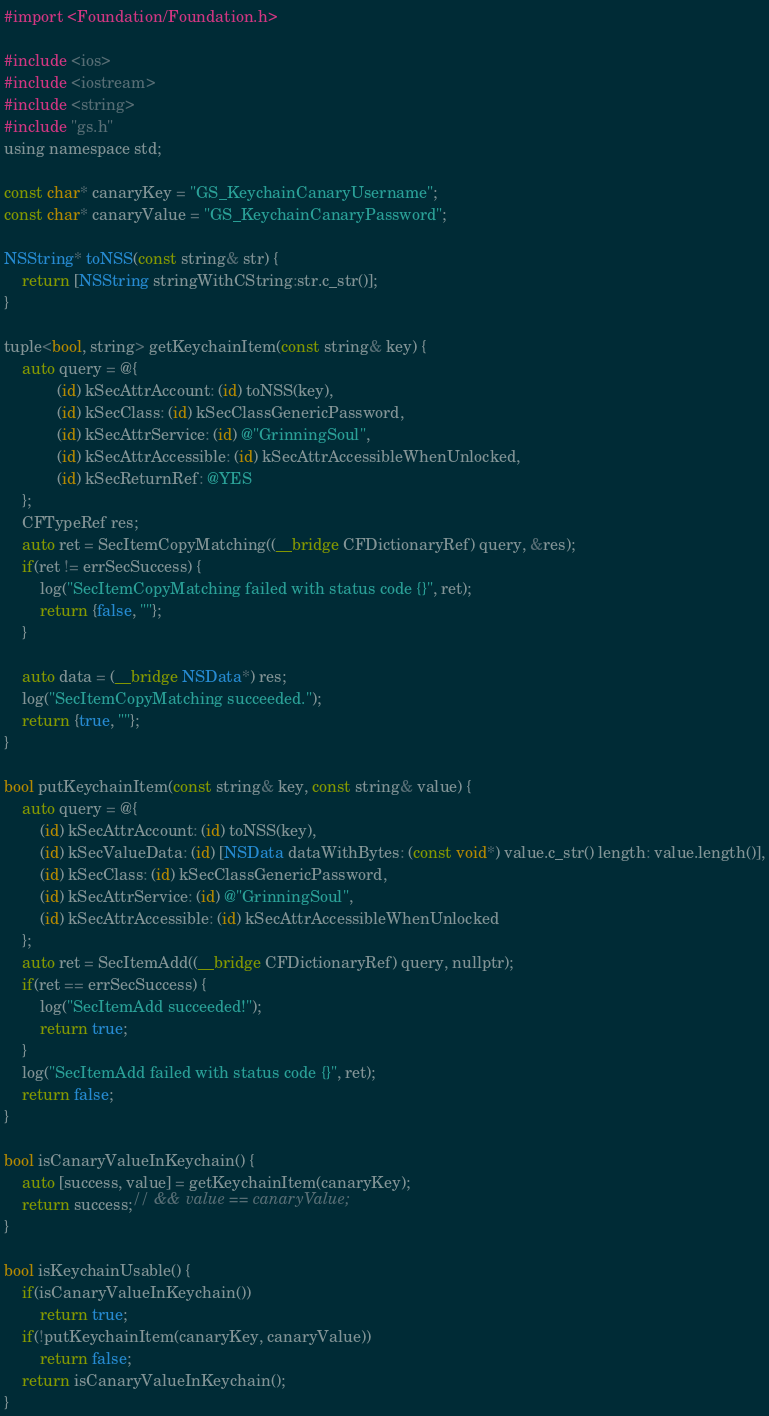Convert code to text. <code><loc_0><loc_0><loc_500><loc_500><_ObjectiveC_>#import <Foundation/Foundation.h>

#include <ios>
#include <iostream>
#include <string>
#include "gs.h"
using namespace std;

const char* canaryKey = "GS_KeychainCanaryUsername";
const char* canaryValue = "GS_KeychainCanaryPassword";

NSString* toNSS(const string& str) {
    return [NSString stringWithCString:str.c_str()];
}

tuple<bool, string> getKeychainItem(const string& key) {
    auto query = @{
            (id) kSecAttrAccount: (id) toNSS(key),
            (id) kSecClass: (id) kSecClassGenericPassword,
            (id) kSecAttrService: (id) @"GrinningSoul",
            (id) kSecAttrAccessible: (id) kSecAttrAccessibleWhenUnlocked,
            (id) kSecReturnRef: @YES
    };
    CFTypeRef res;
    auto ret = SecItemCopyMatching((__bridge CFDictionaryRef) query, &res);
    if(ret != errSecSuccess) {
        log("SecItemCopyMatching failed with status code {}", ret);
        return {false, ""};
    }

    auto data = (__bridge NSData*) res;
    log("SecItemCopyMatching succeeded.");
    return {true, ""};
}

bool putKeychainItem(const string& key, const string& value) {
    auto query = @{
        (id) kSecAttrAccount: (id) toNSS(key),
        (id) kSecValueData: (id) [NSData dataWithBytes: (const void*) value.c_str() length: value.length()],
        (id) kSecClass: (id) kSecClassGenericPassword,
        (id) kSecAttrService: (id) @"GrinningSoul",
        (id) kSecAttrAccessible: (id) kSecAttrAccessibleWhenUnlocked
    };
    auto ret = SecItemAdd((__bridge CFDictionaryRef) query, nullptr);
    if(ret == errSecSuccess) {
        log("SecItemAdd succeeded!");
        return true;
    }
    log("SecItemAdd failed with status code {}", ret);
    return false;
}

bool isCanaryValueInKeychain() {
    auto [success, value] = getKeychainItem(canaryKey);
    return success;// && value == canaryValue;
}

bool isKeychainUsable() {
    if(isCanaryValueInKeychain())
        return true;
    if(!putKeychainItem(canaryKey, canaryValue))
        return false;
    return isCanaryValueInKeychain();
}
</code> 